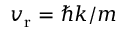Convert formula to latex. <formula><loc_0><loc_0><loc_500><loc_500>v _ { r } = \hbar { k } / m</formula> 